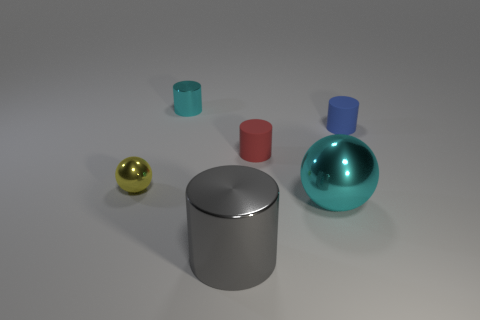There is a thing in front of the large cyan ball; what shape is it?
Your answer should be very brief. Cylinder. What number of things are both on the right side of the yellow metal ball and behind the large metallic cylinder?
Offer a very short reply. 4. Do the yellow object and the shiny cylinder behind the small yellow shiny ball have the same size?
Your answer should be compact. Yes. There is a cyan shiny object in front of the metal cylinder behind the red matte cylinder that is to the right of the yellow ball; what is its size?
Provide a succinct answer. Large. There is a cyan object in front of the tiny cyan metal thing; what size is it?
Ensure brevity in your answer.  Large. What shape is the large cyan object that is made of the same material as the big gray cylinder?
Your response must be concise. Sphere. Does the tiny thing right of the large cyan thing have the same material as the small cyan object?
Make the answer very short. No. What number of other objects are there of the same material as the large cyan object?
Your answer should be compact. 3. What number of things are rubber cylinders that are on the right side of the big sphere or metal objects in front of the small blue thing?
Your answer should be very brief. 4. Does the small rubber thing that is on the right side of the small red cylinder have the same shape as the tiny metal object in front of the small blue matte cylinder?
Give a very brief answer. No. 